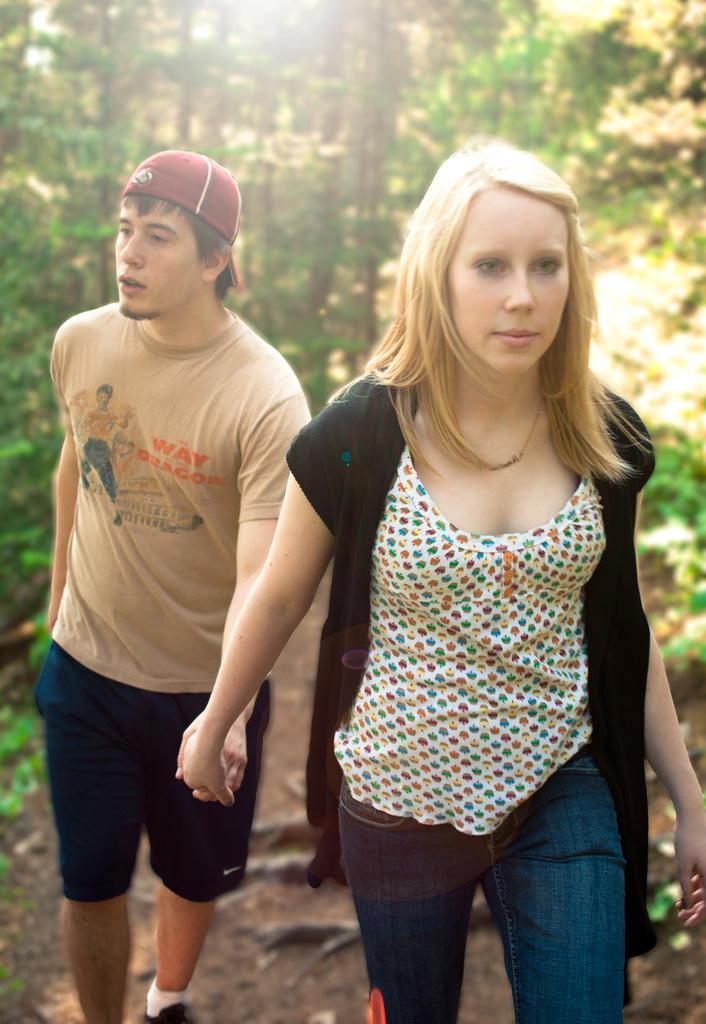In one or two sentences, can you explain what this image depicts? In this image in the foreground there is one man and one woman who are holding hands and walking, and in the background there are trees. At the bottom there is sand. 